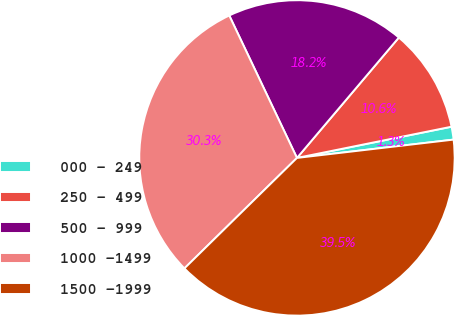<chart> <loc_0><loc_0><loc_500><loc_500><pie_chart><fcel>000 - 249<fcel>250 - 499<fcel>500 - 999<fcel>1000 -1499<fcel>1500 -1999<nl><fcel>1.32%<fcel>10.65%<fcel>18.24%<fcel>30.29%<fcel>39.5%<nl></chart> 